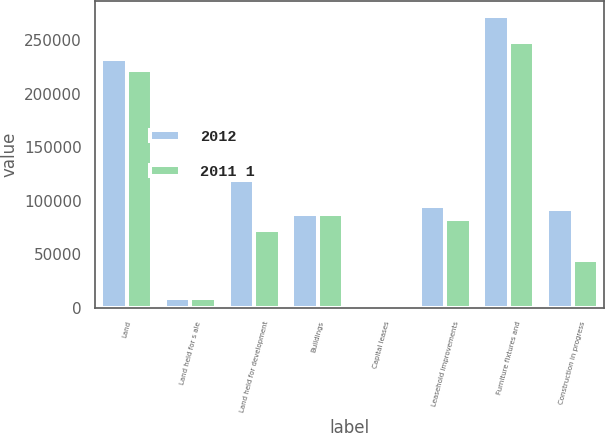Convert chart to OTSL. <chart><loc_0><loc_0><loc_500><loc_500><stacked_bar_chart><ecel><fcel>Land<fcel>Land held for s ale<fcel>Land held for development<fcel>Buildings<fcel>Capital leases<fcel>Leasehold improvements<fcel>Furniture fixtures and<fcel>Construction in progress<nl><fcel>2012<fcel>232274<fcel>8446<fcel>119087<fcel>87840<fcel>1739<fcel>95110<fcel>273280<fcel>92393<nl><fcel>2011 1<fcel>221997<fcel>8693<fcel>72168<fcel>87840<fcel>1739<fcel>83287<fcel>248944<fcel>44894<nl></chart> 